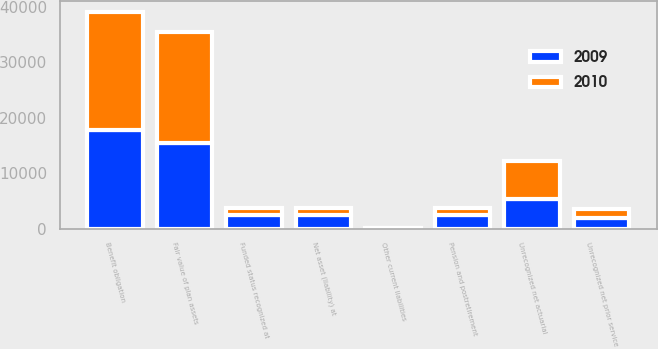Convert chart to OTSL. <chart><loc_0><loc_0><loc_500><loc_500><stacked_bar_chart><ecel><fcel>Fair value of plan assets<fcel>Benefit obligation<fcel>Funded status recognized at<fcel>Other current liabilities<fcel>Pension and postretirement<fcel>Net asset (liability) at<fcel>Unrecognized net prior service<fcel>Unrecognized net actuarial<nl><fcel>2010<fcel>20092<fcel>21342<fcel>1250<fcel>11<fcel>1281<fcel>1250<fcel>1660<fcel>6833<nl><fcel>2009<fcel>15351<fcel>17763<fcel>2412<fcel>11<fcel>2401<fcel>2412<fcel>1839<fcel>5289<nl></chart> 